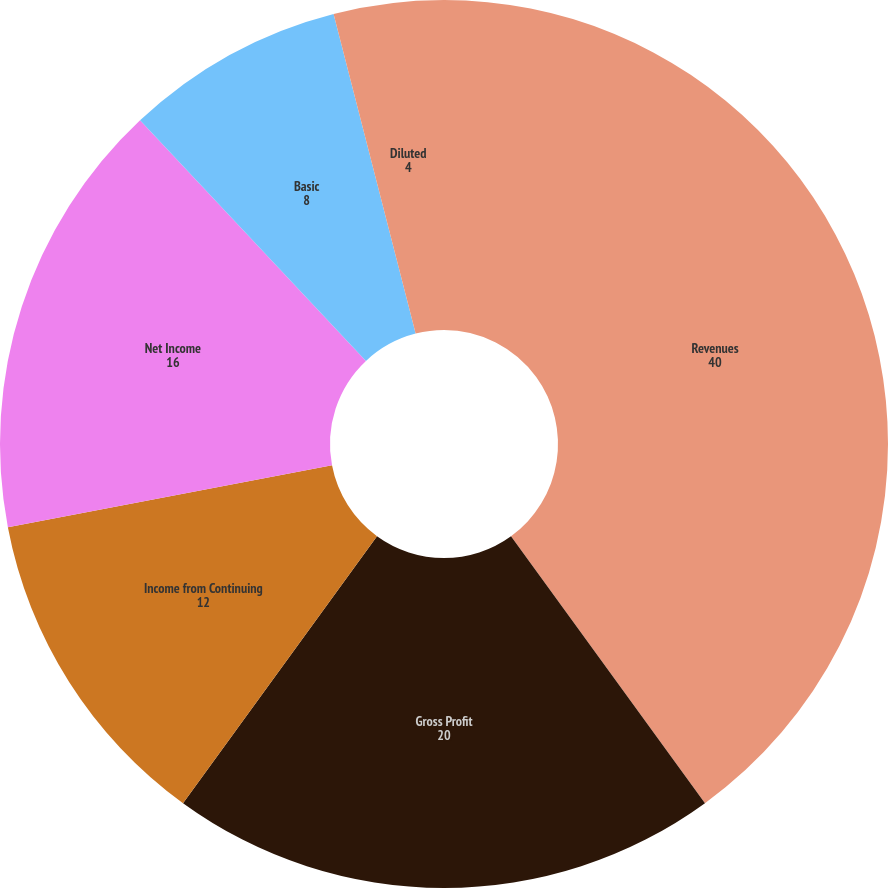Convert chart to OTSL. <chart><loc_0><loc_0><loc_500><loc_500><pie_chart><fcel>Revenues<fcel>Gross Profit<fcel>Income from Continuing<fcel>Net Income<fcel>Basic<fcel>Diluted<fcel>Cash Dividend Declared per<nl><fcel>40.0%<fcel>20.0%<fcel>12.0%<fcel>16.0%<fcel>8.0%<fcel>4.0%<fcel>0.0%<nl></chart> 